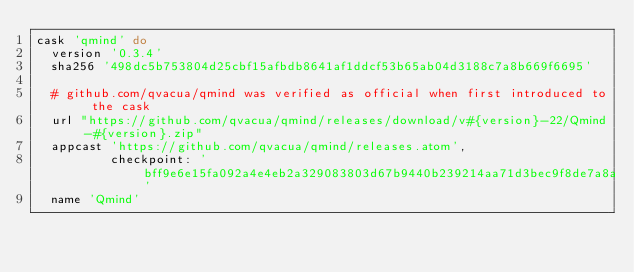<code> <loc_0><loc_0><loc_500><loc_500><_Ruby_>cask 'qmind' do
  version '0.3.4'
  sha256 '498dc5b753804d25cbf15afbdb8641af1ddcf53b65ab04d3188c7a8b669f6695'

  # github.com/qvacua/qmind was verified as official when first introduced to the cask
  url "https://github.com/qvacua/qmind/releases/download/v#{version}-22/Qmind-#{version}.zip"
  appcast 'https://github.com/qvacua/qmind/releases.atom',
          checkpoint: 'bff9e6e15fa092a4e4eb2a329083803d67b9440b239214aa71d3bec9f8de7a8a'
  name 'Qmind'</code> 